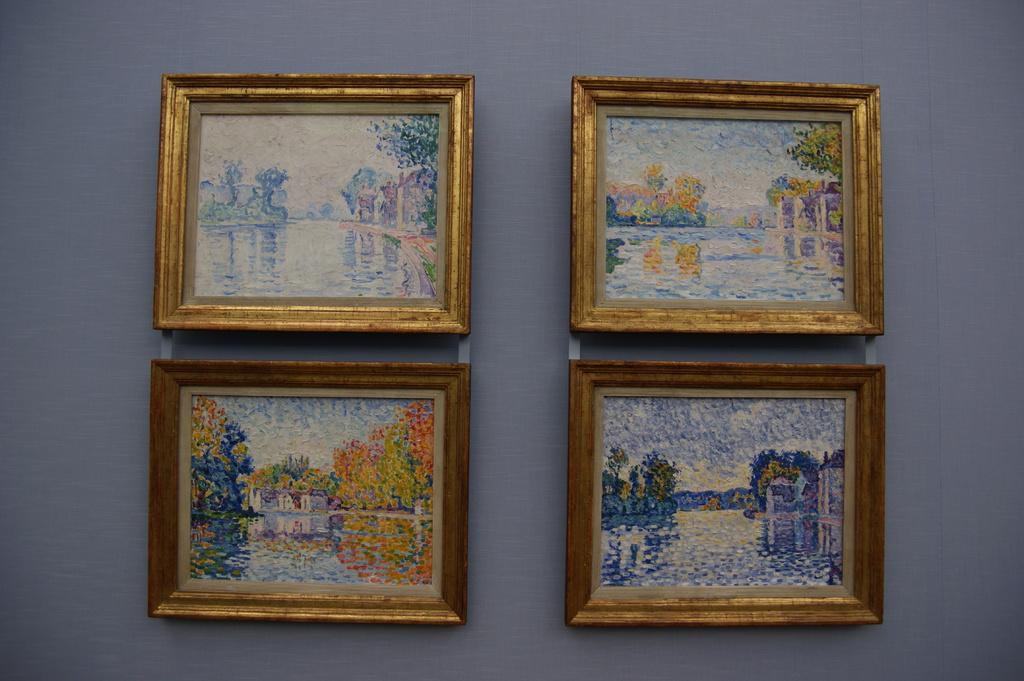How many golden painting frames are visible in the image? There are four golden painting frames in the image. Where are the painting frames located? The painting frames are hanging on a wall. What is the color of the wall on which the painting frames are hanging? The wall is purple in color. What type of plate is being used for the drum during the feast in the image? There is no plate, drum, or feast present in the image; it only features four golden painting frames hanging on a purple wall. 